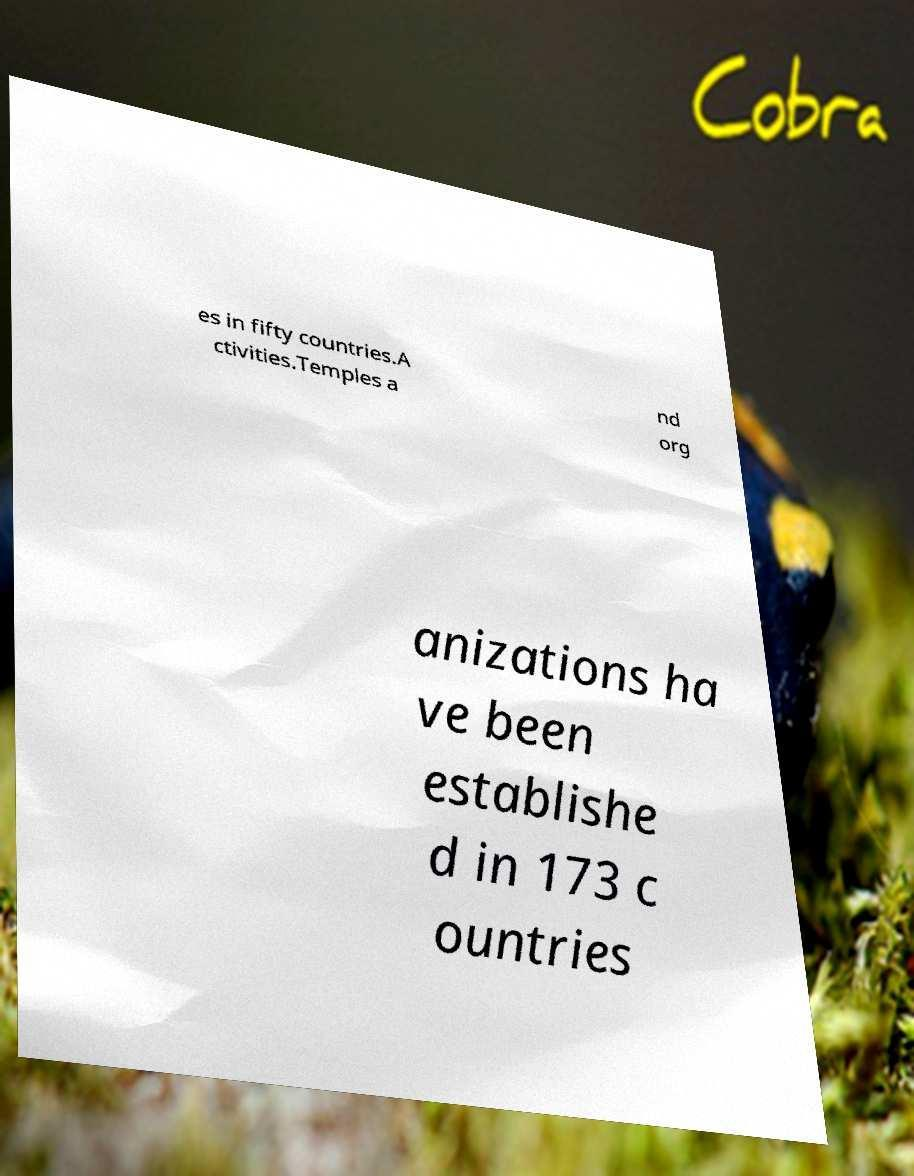Please read and relay the text visible in this image. What does it say? es in fifty countries.A ctivities.Temples a nd org anizations ha ve been establishe d in 173 c ountries 